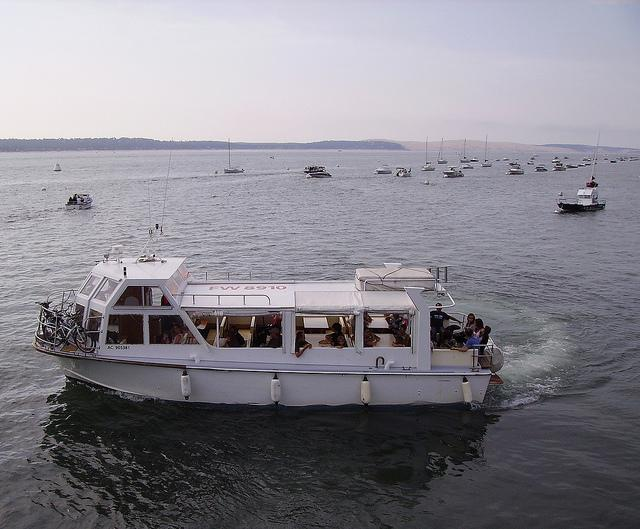What vehicle is stored in front of the boat? Please explain your reasoning. bike. There are bicycles outside of the boat. 